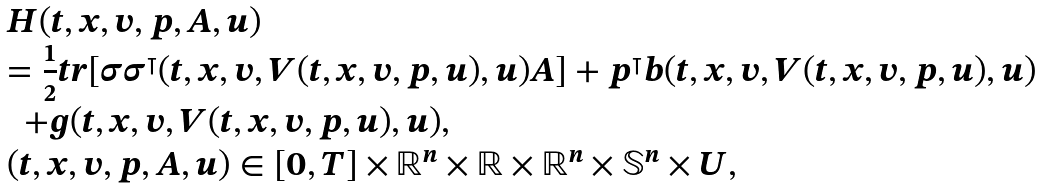<formula> <loc_0><loc_0><loc_500><loc_500>\begin{array} [ c ] { l } H ( t , x , v , p , A , u ) \\ = \frac { 1 } { 2 } t r [ \sigma \sigma ^ { \intercal } ( t , x , v , V ( t , x , v , p , u ) , u ) A ] + p ^ { \intercal } b ( t , x , v , V ( t , x , v , p , u ) , u ) \\ \ \ + g ( t , x , v , V ( t , x , v , p , u ) , u ) , \\ ( t , x , v , p , A , u ) \in [ 0 , T ] \times \mathbb { R } ^ { n } \times \mathbb { R } \times \mathbb { R } ^ { n } \times \mathbb { S } ^ { n } \times U , \end{array}</formula> 